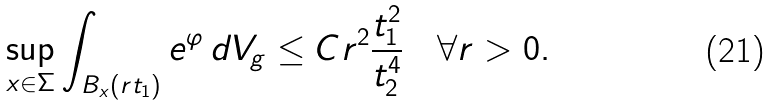<formula> <loc_0><loc_0><loc_500><loc_500>\sup _ { x \in \Sigma } \int _ { B _ { x } ( r t _ { 1 } ) } e ^ { \varphi } \, d V _ { g } \leq C r ^ { 2 } \frac { t _ { 1 } ^ { 2 } } { t _ { 2 } ^ { 4 } } \quad \forall r > 0 .</formula> 